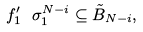<formula> <loc_0><loc_0><loc_500><loc_500>f _ { 1 } ^ { \prime } \ \sigma _ { 1 } ^ { N - i } \subseteq \tilde { B } _ { N - i } ,</formula> 